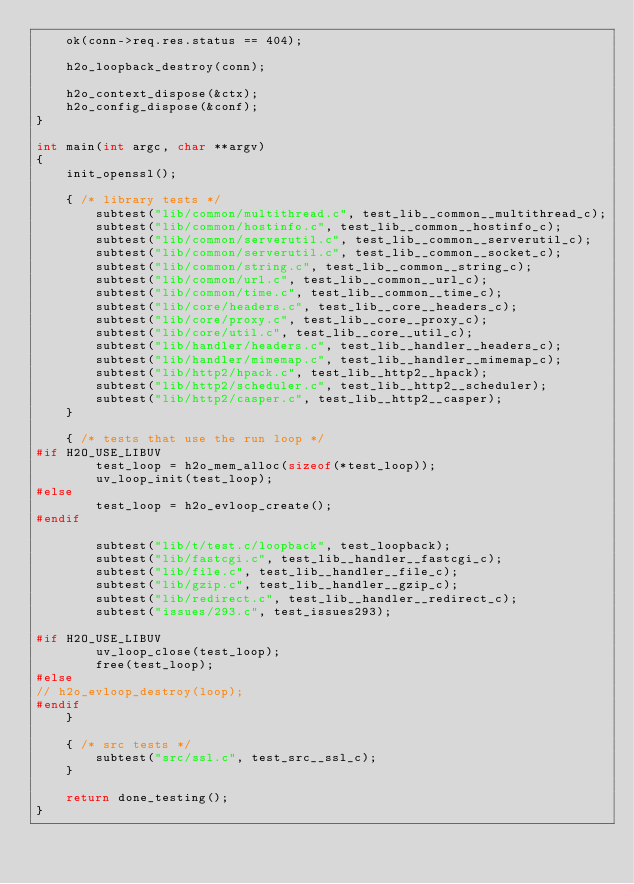<code> <loc_0><loc_0><loc_500><loc_500><_C_>    ok(conn->req.res.status == 404);

    h2o_loopback_destroy(conn);

    h2o_context_dispose(&ctx);
    h2o_config_dispose(&conf);
}

int main(int argc, char **argv)
{
    init_openssl();

    { /* library tests */
        subtest("lib/common/multithread.c", test_lib__common__multithread_c);
        subtest("lib/common/hostinfo.c", test_lib__common__hostinfo_c);
        subtest("lib/common/serverutil.c", test_lib__common__serverutil_c);
        subtest("lib/common/serverutil.c", test_lib__common__socket_c);
        subtest("lib/common/string.c", test_lib__common__string_c);
        subtest("lib/common/url.c", test_lib__common__url_c);
        subtest("lib/common/time.c", test_lib__common__time_c);
        subtest("lib/core/headers.c", test_lib__core__headers_c);
        subtest("lib/core/proxy.c", test_lib__core__proxy_c);
        subtest("lib/core/util.c", test_lib__core__util_c);
        subtest("lib/handler/headers.c", test_lib__handler__headers_c);
        subtest("lib/handler/mimemap.c", test_lib__handler__mimemap_c);
        subtest("lib/http2/hpack.c", test_lib__http2__hpack);
        subtest("lib/http2/scheduler.c", test_lib__http2__scheduler);
        subtest("lib/http2/casper.c", test_lib__http2__casper);
    }

    { /* tests that use the run loop */
#if H2O_USE_LIBUV
        test_loop = h2o_mem_alloc(sizeof(*test_loop));
        uv_loop_init(test_loop);
#else
        test_loop = h2o_evloop_create();
#endif

        subtest("lib/t/test.c/loopback", test_loopback);
        subtest("lib/fastcgi.c", test_lib__handler__fastcgi_c);
        subtest("lib/file.c", test_lib__handler__file_c);
        subtest("lib/gzip.c", test_lib__handler__gzip_c);
        subtest("lib/redirect.c", test_lib__handler__redirect_c);
        subtest("issues/293.c", test_issues293);

#if H2O_USE_LIBUV
        uv_loop_close(test_loop);
        free(test_loop);
#else
// h2o_evloop_destroy(loop);
#endif
    }

    { /* src tests */
        subtest("src/ssl.c", test_src__ssl_c);
    }

    return done_testing();
}
</code> 